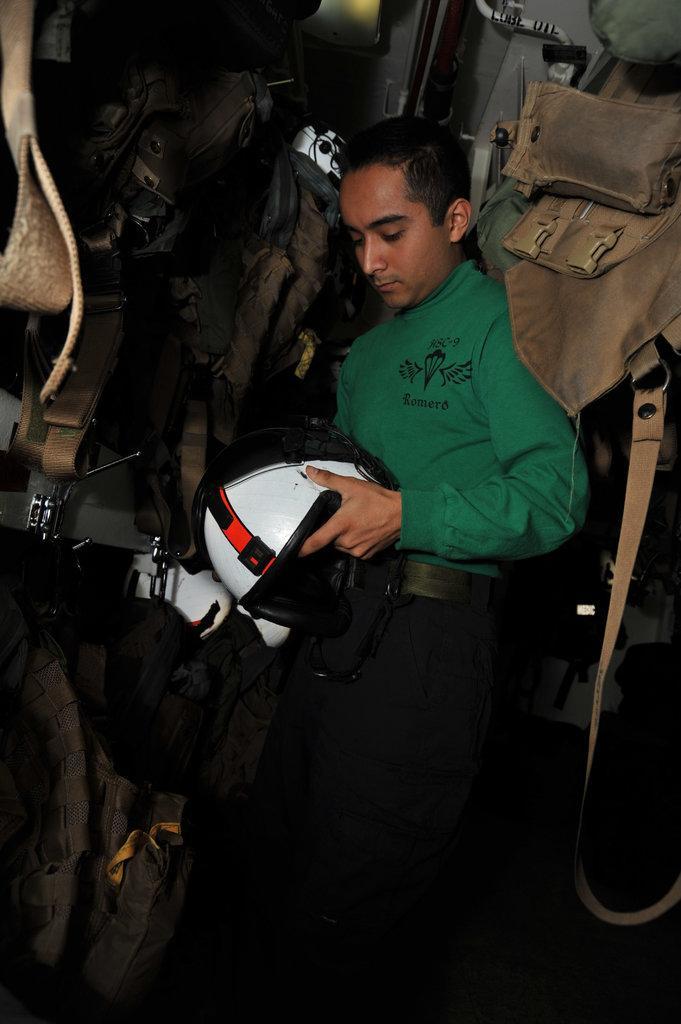Can you describe this image briefly? The picture consists of jackets and we can see a person holding helmet. 